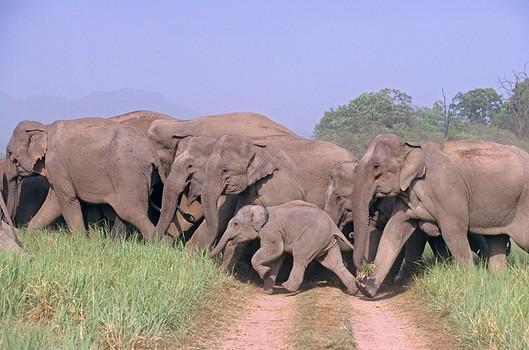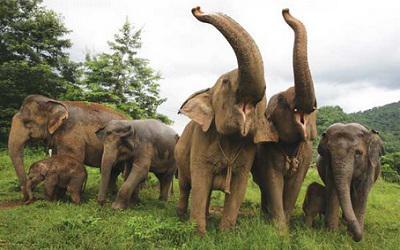The first image is the image on the left, the second image is the image on the right. Evaluate the accuracy of this statement regarding the images: "An image shows just one elephant in the foreground.". Is it true? Answer yes or no. No. 